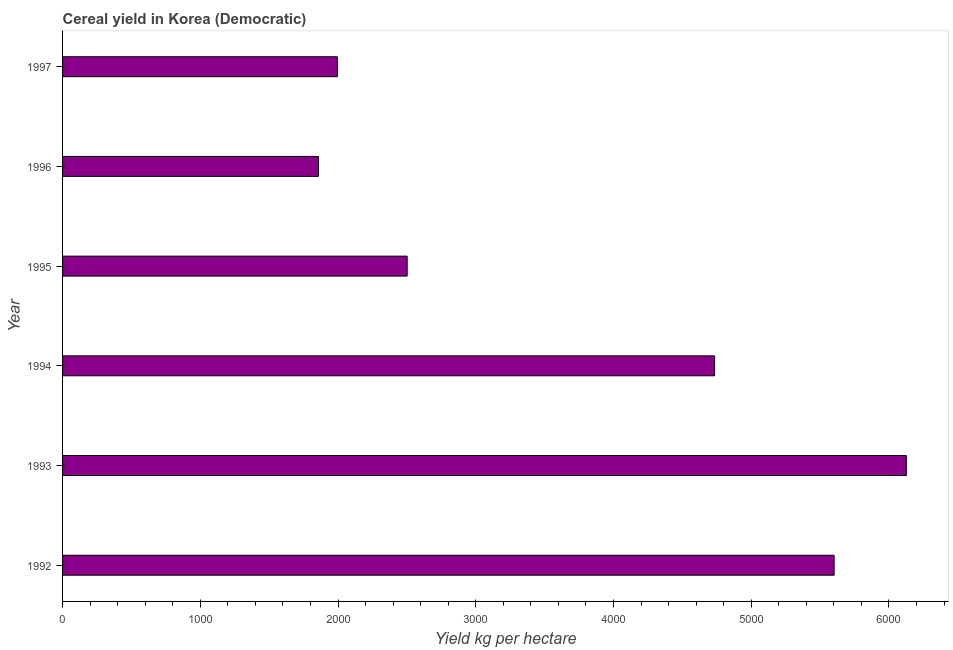Does the graph contain any zero values?
Keep it short and to the point. No. What is the title of the graph?
Your response must be concise. Cereal yield in Korea (Democratic). What is the label or title of the X-axis?
Provide a short and direct response. Yield kg per hectare. What is the cereal yield in 1995?
Make the answer very short. 2502.13. Across all years, what is the maximum cereal yield?
Ensure brevity in your answer.  6126.36. Across all years, what is the minimum cereal yield?
Offer a very short reply. 1857.58. In which year was the cereal yield maximum?
Provide a succinct answer. 1993. What is the sum of the cereal yield?
Keep it short and to the point. 2.28e+04. What is the difference between the cereal yield in 1993 and 1994?
Keep it short and to the point. 1391.98. What is the average cereal yield per year?
Make the answer very short. 3802.96. What is the median cereal yield?
Give a very brief answer. 3618.25. Do a majority of the years between 1993 and 1996 (inclusive) have cereal yield greater than 5200 kg per hectare?
Provide a succinct answer. No. What is the ratio of the cereal yield in 1992 to that in 1993?
Your response must be concise. 0.91. Is the difference between the cereal yield in 1992 and 1993 greater than the difference between any two years?
Give a very brief answer. No. What is the difference between the highest and the second highest cereal yield?
Give a very brief answer. 524.15. Is the sum of the cereal yield in 1992 and 1994 greater than the maximum cereal yield across all years?
Your answer should be very brief. Yes. What is the difference between the highest and the lowest cereal yield?
Offer a very short reply. 4268.77. In how many years, is the cereal yield greater than the average cereal yield taken over all years?
Your response must be concise. 3. How many bars are there?
Provide a short and direct response. 6. How many years are there in the graph?
Give a very brief answer. 6. Are the values on the major ticks of X-axis written in scientific E-notation?
Provide a short and direct response. No. What is the Yield kg per hectare in 1992?
Your response must be concise. 5602.21. What is the Yield kg per hectare in 1993?
Offer a very short reply. 6126.36. What is the Yield kg per hectare in 1994?
Keep it short and to the point. 4734.38. What is the Yield kg per hectare of 1995?
Make the answer very short. 2502.13. What is the Yield kg per hectare in 1996?
Your answer should be very brief. 1857.58. What is the Yield kg per hectare in 1997?
Make the answer very short. 1995.1. What is the difference between the Yield kg per hectare in 1992 and 1993?
Ensure brevity in your answer.  -524.15. What is the difference between the Yield kg per hectare in 1992 and 1994?
Your answer should be compact. 867.83. What is the difference between the Yield kg per hectare in 1992 and 1995?
Offer a very short reply. 3100.08. What is the difference between the Yield kg per hectare in 1992 and 1996?
Offer a very short reply. 3744.62. What is the difference between the Yield kg per hectare in 1992 and 1997?
Offer a very short reply. 3607.11. What is the difference between the Yield kg per hectare in 1993 and 1994?
Your response must be concise. 1391.98. What is the difference between the Yield kg per hectare in 1993 and 1995?
Provide a succinct answer. 3624.23. What is the difference between the Yield kg per hectare in 1993 and 1996?
Your answer should be compact. 4268.77. What is the difference between the Yield kg per hectare in 1993 and 1997?
Your response must be concise. 4131.26. What is the difference between the Yield kg per hectare in 1994 and 1995?
Your answer should be compact. 2232.25. What is the difference between the Yield kg per hectare in 1994 and 1996?
Offer a terse response. 2876.8. What is the difference between the Yield kg per hectare in 1994 and 1997?
Keep it short and to the point. 2739.28. What is the difference between the Yield kg per hectare in 1995 and 1996?
Provide a succinct answer. 644.55. What is the difference between the Yield kg per hectare in 1995 and 1997?
Your response must be concise. 507.03. What is the difference between the Yield kg per hectare in 1996 and 1997?
Your answer should be compact. -137.52. What is the ratio of the Yield kg per hectare in 1992 to that in 1993?
Provide a short and direct response. 0.91. What is the ratio of the Yield kg per hectare in 1992 to that in 1994?
Provide a succinct answer. 1.18. What is the ratio of the Yield kg per hectare in 1992 to that in 1995?
Ensure brevity in your answer.  2.24. What is the ratio of the Yield kg per hectare in 1992 to that in 1996?
Offer a very short reply. 3.02. What is the ratio of the Yield kg per hectare in 1992 to that in 1997?
Provide a short and direct response. 2.81. What is the ratio of the Yield kg per hectare in 1993 to that in 1994?
Your answer should be very brief. 1.29. What is the ratio of the Yield kg per hectare in 1993 to that in 1995?
Your answer should be very brief. 2.45. What is the ratio of the Yield kg per hectare in 1993 to that in 1996?
Your response must be concise. 3.3. What is the ratio of the Yield kg per hectare in 1993 to that in 1997?
Offer a terse response. 3.07. What is the ratio of the Yield kg per hectare in 1994 to that in 1995?
Your answer should be compact. 1.89. What is the ratio of the Yield kg per hectare in 1994 to that in 1996?
Your answer should be compact. 2.55. What is the ratio of the Yield kg per hectare in 1994 to that in 1997?
Provide a short and direct response. 2.37. What is the ratio of the Yield kg per hectare in 1995 to that in 1996?
Ensure brevity in your answer.  1.35. What is the ratio of the Yield kg per hectare in 1995 to that in 1997?
Keep it short and to the point. 1.25. What is the ratio of the Yield kg per hectare in 1996 to that in 1997?
Provide a short and direct response. 0.93. 